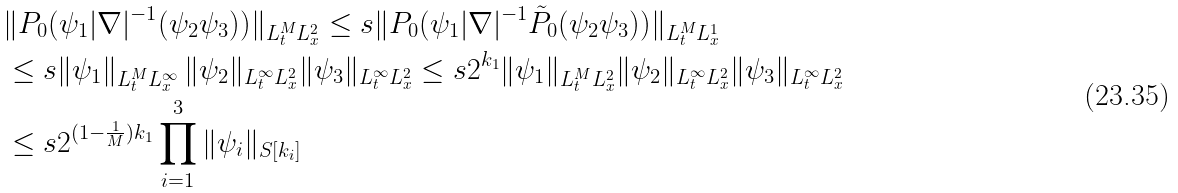<formula> <loc_0><loc_0><loc_500><loc_500>& \| P _ { 0 } ( \psi _ { 1 } | \nabla | ^ { - 1 } ( \psi _ { 2 } \psi _ { 3 } ) ) \| _ { L ^ { M } _ { t } L ^ { 2 } _ { x } } \leq s \| P _ { 0 } ( \psi _ { 1 } | \nabla | ^ { - 1 } \tilde { P } _ { 0 } ( \psi _ { 2 } \psi _ { 3 } ) ) \| _ { L ^ { M } _ { t } L ^ { 1 } _ { x } } \\ & \leq s \| \psi _ { 1 } \| _ { L ^ { M } _ { t } L ^ { \infty } _ { x } } \, \| \psi _ { 2 } \| _ { L ^ { \infty } _ { t } L ^ { 2 } _ { x } } \| \psi _ { 3 } \| _ { L ^ { \infty } _ { t } L ^ { 2 } _ { x } } \leq s 2 ^ { k _ { 1 } } \| \psi _ { 1 } \| _ { L ^ { M } _ { t } L ^ { 2 } _ { x } } \| \psi _ { 2 } \| _ { L ^ { \infty } _ { t } L ^ { 2 } _ { x } } \| \psi _ { 3 } \| _ { L ^ { \infty } _ { t } L ^ { 2 } _ { x } } \\ & \leq s 2 ^ { ( 1 - \frac { 1 } { M } ) k _ { 1 } } \prod _ { i = 1 } ^ { 3 } \| \psi _ { i } \| _ { S [ k _ { i } ] }</formula> 